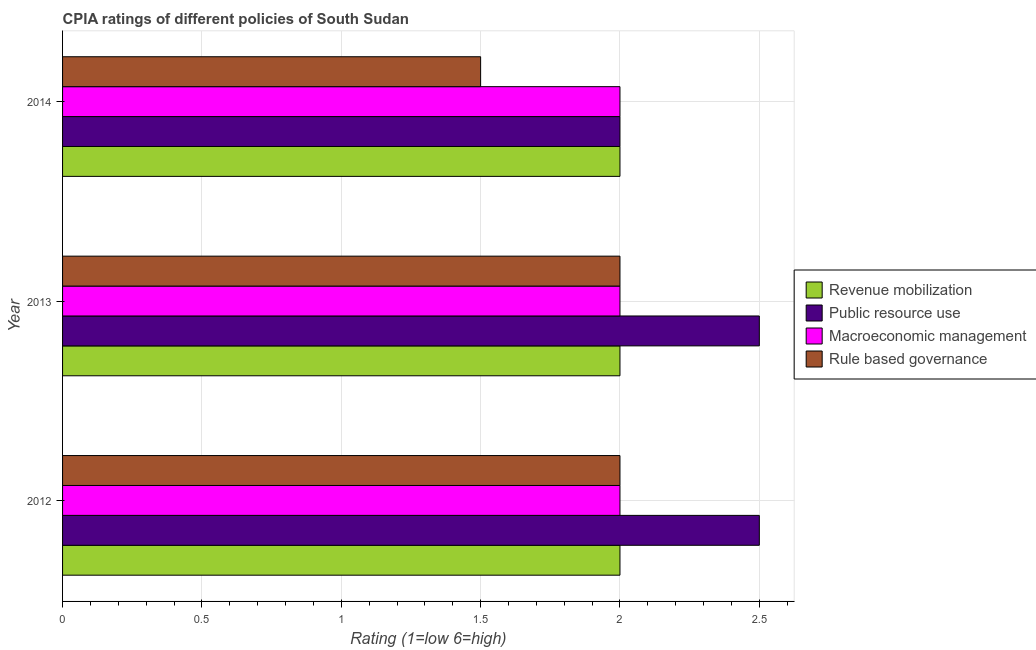Are the number of bars per tick equal to the number of legend labels?
Make the answer very short. Yes. Are the number of bars on each tick of the Y-axis equal?
Your answer should be very brief. Yes. How many bars are there on the 2nd tick from the bottom?
Offer a terse response. 4. What is the label of the 2nd group of bars from the top?
Your response must be concise. 2013. In how many cases, is the number of bars for a given year not equal to the number of legend labels?
Ensure brevity in your answer.  0. What is the cpia rating of rule based governance in 2012?
Ensure brevity in your answer.  2. Across all years, what is the minimum cpia rating of rule based governance?
Make the answer very short. 1.5. In which year was the cpia rating of public resource use maximum?
Make the answer very short. 2012. In which year was the cpia rating of revenue mobilization minimum?
Your answer should be compact. 2012. What is the total cpia rating of macroeconomic management in the graph?
Ensure brevity in your answer.  6. What is the difference between the cpia rating of public resource use in 2012 and that in 2013?
Provide a succinct answer. 0. What is the average cpia rating of rule based governance per year?
Your answer should be very brief. 1.83. In the year 2012, what is the difference between the cpia rating of revenue mobilization and cpia rating of public resource use?
Make the answer very short. -0.5. In how many years, is the cpia rating of macroeconomic management greater than 1.9 ?
Your answer should be very brief. 3. In how many years, is the cpia rating of rule based governance greater than the average cpia rating of rule based governance taken over all years?
Provide a succinct answer. 2. Is it the case that in every year, the sum of the cpia rating of rule based governance and cpia rating of macroeconomic management is greater than the sum of cpia rating of public resource use and cpia rating of revenue mobilization?
Your answer should be very brief. No. What does the 2nd bar from the top in 2013 represents?
Keep it short and to the point. Macroeconomic management. What does the 2nd bar from the bottom in 2014 represents?
Provide a short and direct response. Public resource use. Is it the case that in every year, the sum of the cpia rating of revenue mobilization and cpia rating of public resource use is greater than the cpia rating of macroeconomic management?
Your response must be concise. Yes. How many bars are there?
Provide a short and direct response. 12. Are all the bars in the graph horizontal?
Your answer should be very brief. Yes. How many years are there in the graph?
Provide a succinct answer. 3. What is the difference between two consecutive major ticks on the X-axis?
Keep it short and to the point. 0.5. Are the values on the major ticks of X-axis written in scientific E-notation?
Give a very brief answer. No. Does the graph contain any zero values?
Give a very brief answer. No. Does the graph contain grids?
Give a very brief answer. Yes. What is the title of the graph?
Provide a succinct answer. CPIA ratings of different policies of South Sudan. What is the label or title of the X-axis?
Make the answer very short. Rating (1=low 6=high). What is the Rating (1=low 6=high) in Public resource use in 2012?
Make the answer very short. 2.5. What is the Rating (1=low 6=high) in Macroeconomic management in 2013?
Your answer should be compact. 2. What is the Rating (1=low 6=high) in Rule based governance in 2013?
Keep it short and to the point. 2. What is the Rating (1=low 6=high) of Public resource use in 2014?
Offer a very short reply. 2. What is the Rating (1=low 6=high) in Macroeconomic management in 2014?
Give a very brief answer. 2. What is the Rating (1=low 6=high) of Rule based governance in 2014?
Offer a very short reply. 1.5. Across all years, what is the maximum Rating (1=low 6=high) in Rule based governance?
Ensure brevity in your answer.  2. Across all years, what is the minimum Rating (1=low 6=high) of Revenue mobilization?
Offer a terse response. 2. Across all years, what is the minimum Rating (1=low 6=high) in Public resource use?
Provide a short and direct response. 2. Across all years, what is the minimum Rating (1=low 6=high) of Macroeconomic management?
Offer a terse response. 2. What is the total Rating (1=low 6=high) in Revenue mobilization in the graph?
Provide a short and direct response. 6. What is the total Rating (1=low 6=high) of Macroeconomic management in the graph?
Provide a short and direct response. 6. What is the difference between the Rating (1=low 6=high) in Revenue mobilization in 2012 and that in 2013?
Keep it short and to the point. 0. What is the difference between the Rating (1=low 6=high) of Public resource use in 2012 and that in 2013?
Your response must be concise. 0. What is the difference between the Rating (1=low 6=high) in Macroeconomic management in 2012 and that in 2013?
Offer a very short reply. 0. What is the difference between the Rating (1=low 6=high) in Rule based governance in 2012 and that in 2013?
Your answer should be compact. 0. What is the difference between the Rating (1=low 6=high) in Macroeconomic management in 2012 and that in 2014?
Provide a succinct answer. 0. What is the difference between the Rating (1=low 6=high) in Revenue mobilization in 2013 and that in 2014?
Keep it short and to the point. 0. What is the difference between the Rating (1=low 6=high) in Revenue mobilization in 2012 and the Rating (1=low 6=high) in Public resource use in 2013?
Your answer should be very brief. -0.5. What is the difference between the Rating (1=low 6=high) of Public resource use in 2012 and the Rating (1=low 6=high) of Rule based governance in 2014?
Offer a very short reply. 1. What is the difference between the Rating (1=low 6=high) in Revenue mobilization in 2013 and the Rating (1=low 6=high) in Public resource use in 2014?
Your answer should be compact. 0. What is the difference between the Rating (1=low 6=high) of Public resource use in 2013 and the Rating (1=low 6=high) of Rule based governance in 2014?
Your answer should be compact. 1. What is the difference between the Rating (1=low 6=high) in Macroeconomic management in 2013 and the Rating (1=low 6=high) in Rule based governance in 2014?
Your response must be concise. 0.5. What is the average Rating (1=low 6=high) of Public resource use per year?
Your answer should be very brief. 2.33. What is the average Rating (1=low 6=high) in Macroeconomic management per year?
Give a very brief answer. 2. What is the average Rating (1=low 6=high) of Rule based governance per year?
Keep it short and to the point. 1.83. In the year 2012, what is the difference between the Rating (1=low 6=high) of Revenue mobilization and Rating (1=low 6=high) of Public resource use?
Your answer should be compact. -0.5. In the year 2012, what is the difference between the Rating (1=low 6=high) in Revenue mobilization and Rating (1=low 6=high) in Macroeconomic management?
Offer a very short reply. 0. In the year 2012, what is the difference between the Rating (1=low 6=high) in Public resource use and Rating (1=low 6=high) in Macroeconomic management?
Offer a very short reply. 0.5. In the year 2012, what is the difference between the Rating (1=low 6=high) of Macroeconomic management and Rating (1=low 6=high) of Rule based governance?
Keep it short and to the point. 0. In the year 2013, what is the difference between the Rating (1=low 6=high) of Public resource use and Rating (1=low 6=high) of Macroeconomic management?
Offer a terse response. 0.5. In the year 2013, what is the difference between the Rating (1=low 6=high) in Public resource use and Rating (1=low 6=high) in Rule based governance?
Your response must be concise. 0.5. In the year 2014, what is the difference between the Rating (1=low 6=high) of Revenue mobilization and Rating (1=low 6=high) of Macroeconomic management?
Your answer should be very brief. 0. In the year 2014, what is the difference between the Rating (1=low 6=high) in Revenue mobilization and Rating (1=low 6=high) in Rule based governance?
Your answer should be compact. 0.5. In the year 2014, what is the difference between the Rating (1=low 6=high) of Macroeconomic management and Rating (1=low 6=high) of Rule based governance?
Offer a terse response. 0.5. What is the ratio of the Rating (1=low 6=high) of Revenue mobilization in 2012 to that in 2013?
Make the answer very short. 1. What is the ratio of the Rating (1=low 6=high) of Rule based governance in 2012 to that in 2013?
Ensure brevity in your answer.  1. What is the ratio of the Rating (1=low 6=high) of Macroeconomic management in 2012 to that in 2014?
Your response must be concise. 1. What is the ratio of the Rating (1=low 6=high) in Rule based governance in 2012 to that in 2014?
Offer a terse response. 1.33. What is the difference between the highest and the second highest Rating (1=low 6=high) of Revenue mobilization?
Offer a terse response. 0. What is the difference between the highest and the second highest Rating (1=low 6=high) of Public resource use?
Your answer should be compact. 0. What is the difference between the highest and the second highest Rating (1=low 6=high) in Macroeconomic management?
Keep it short and to the point. 0. What is the difference between the highest and the lowest Rating (1=low 6=high) in Rule based governance?
Give a very brief answer. 0.5. 